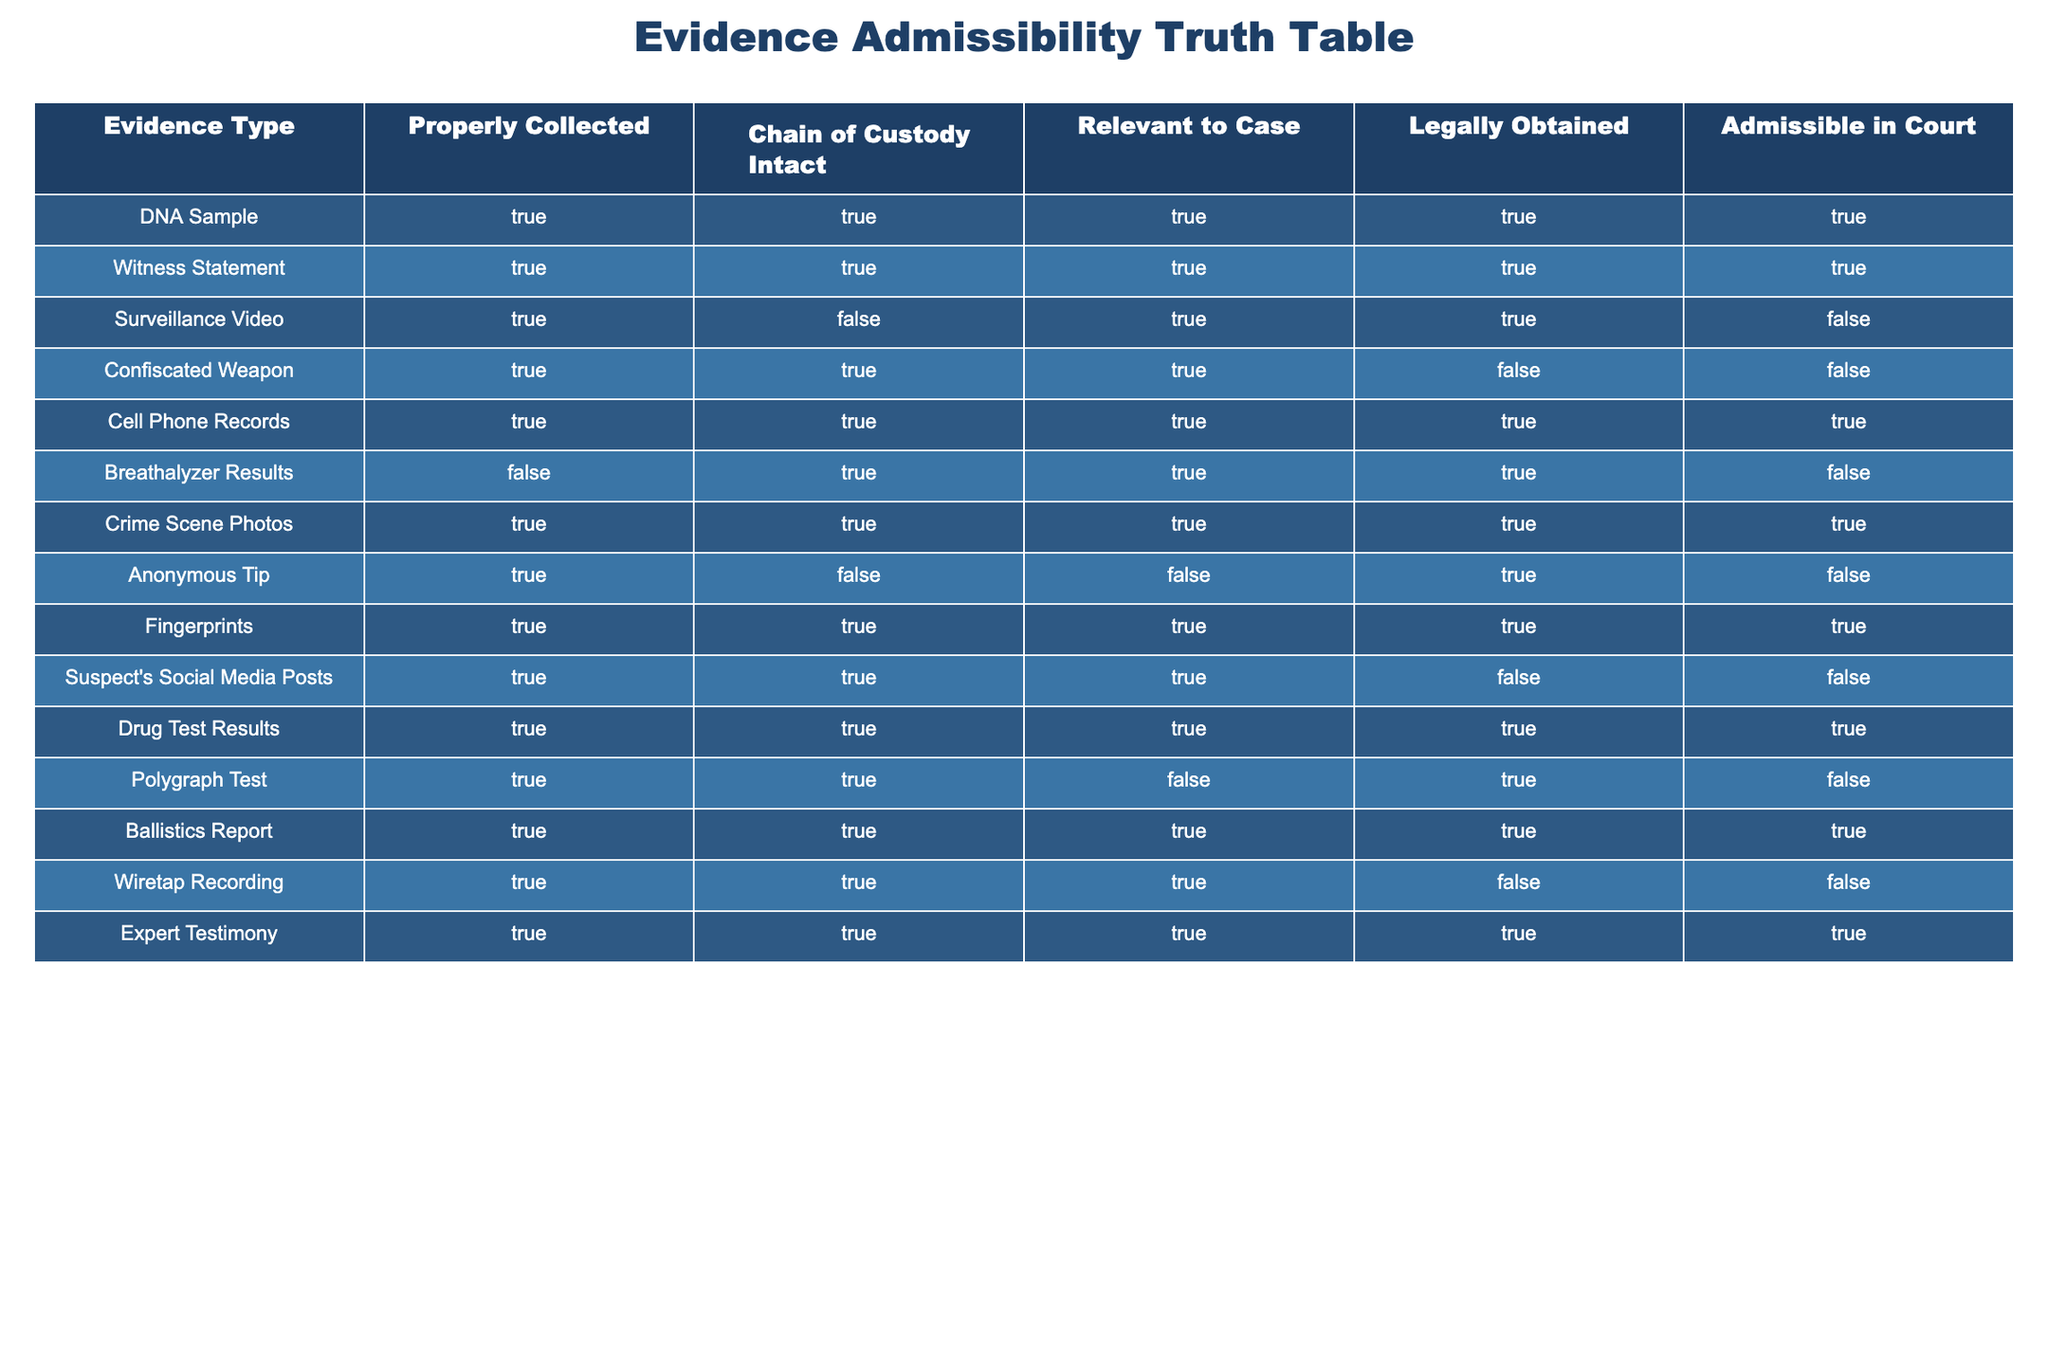What type of evidence is admissible in court if it is properly collected, has intact chain of custody, is relevant to the case, and is legally obtained? By examining the table, we can see that the evidence types that meet all these criteria (TRUE for all four columns) are DNA Sample, Witness Statement, Cell Phone Records, Crime Scene Photos, Fingerprints, Drug Test Results, Ballistics Report, and Expert Testimony. These are examples of evidence that are admissible in court under the specified conditions.
Answer: DNA Sample, Witness Statement, Cell Phone Records, Crime Scene Photos, Fingerprints, Drug Test Results, Ballistics Report, Expert Testimony Is a witness statement legally obtained? From the table, we observe that the Witness Statement is marked as TRUE in the "Legally Obtained" column, confirming that it is valid under the law. Thus, a witness statement is legally obtained.
Answer: Yes How many types of evidence listed are not admissible in court? To find the number of evidence types that are not admissible in court, we look for the entries in the "Admissible in Court" column marked as FALSE. These types are Surveillance Video, Confiscated Weapon, Breathalyzer Results, Anonymous Tip, Suspect's Social Media Posts, Wiretap Recording. Counting them gives us a total of six types that are not admissible.
Answer: 6 Are there any types of evidence that are admissible in court but were not properly collected? We need to check the "Properly Collected" column for any types marked as FALSE while simultaneously looking at the "Admissible in Court" column. The only evidence type that meets these criteria is Breathalyzer Results, which is not properly collected (FALSE) but still is ruled as inadmissible (FALSE). There are no such cases where the evidence is admitted despite improper collection.
Answer: No What is the total number of pieces of evidence that were relevant to the case? Reviewing the "Relevant to Case" column, we count how many entries are marked TRUE. These types of evidence include DNA Sample, Witness Statement, Surveillance Video, Confiscated Weapon, Cell Phone Records, Crime Scene Photos, Fingerprints, Suspect's Social Media Posts, Drug Test Results, Polygraph Test, Ballistics Report, and Expert Testimony. This sums up to a total of 12 relevant pieces of evidence.
Answer: 12 Which type of evidence has an intact chain of custody but is not admissible in court? By examining the "Chain of Custody Intact" column for TRUE and the "Admissible in Court" column for FALSE, we find that the only type of evidence fitting this criteria is Surveillance Video. This evidence maintains the chain of custody but is ruled inadmissible in court.
Answer: Surveillance Video How many evidence types were both properly collected and relevant to the case? By looking at the columns "Properly Collected" and "Relevant to Case," we can filter the types where both are marked TRUE. They are DNA Sample, Witness Statement, Cell Phone Records, Crime Scene Photos, Fingerprints, Drug Test Results, Ballistics Report, and Expert Testimony. This gives us a total of eight pieces of evidence that satisfy both conditions.
Answer: 8 Is the breathalyzer result admissible in court? Checking the "Admissible in Court" column, we see that Breathalyzer Results is marked FALSE. Therefore, breathalyzer results are not admissible in court.
Answer: No 